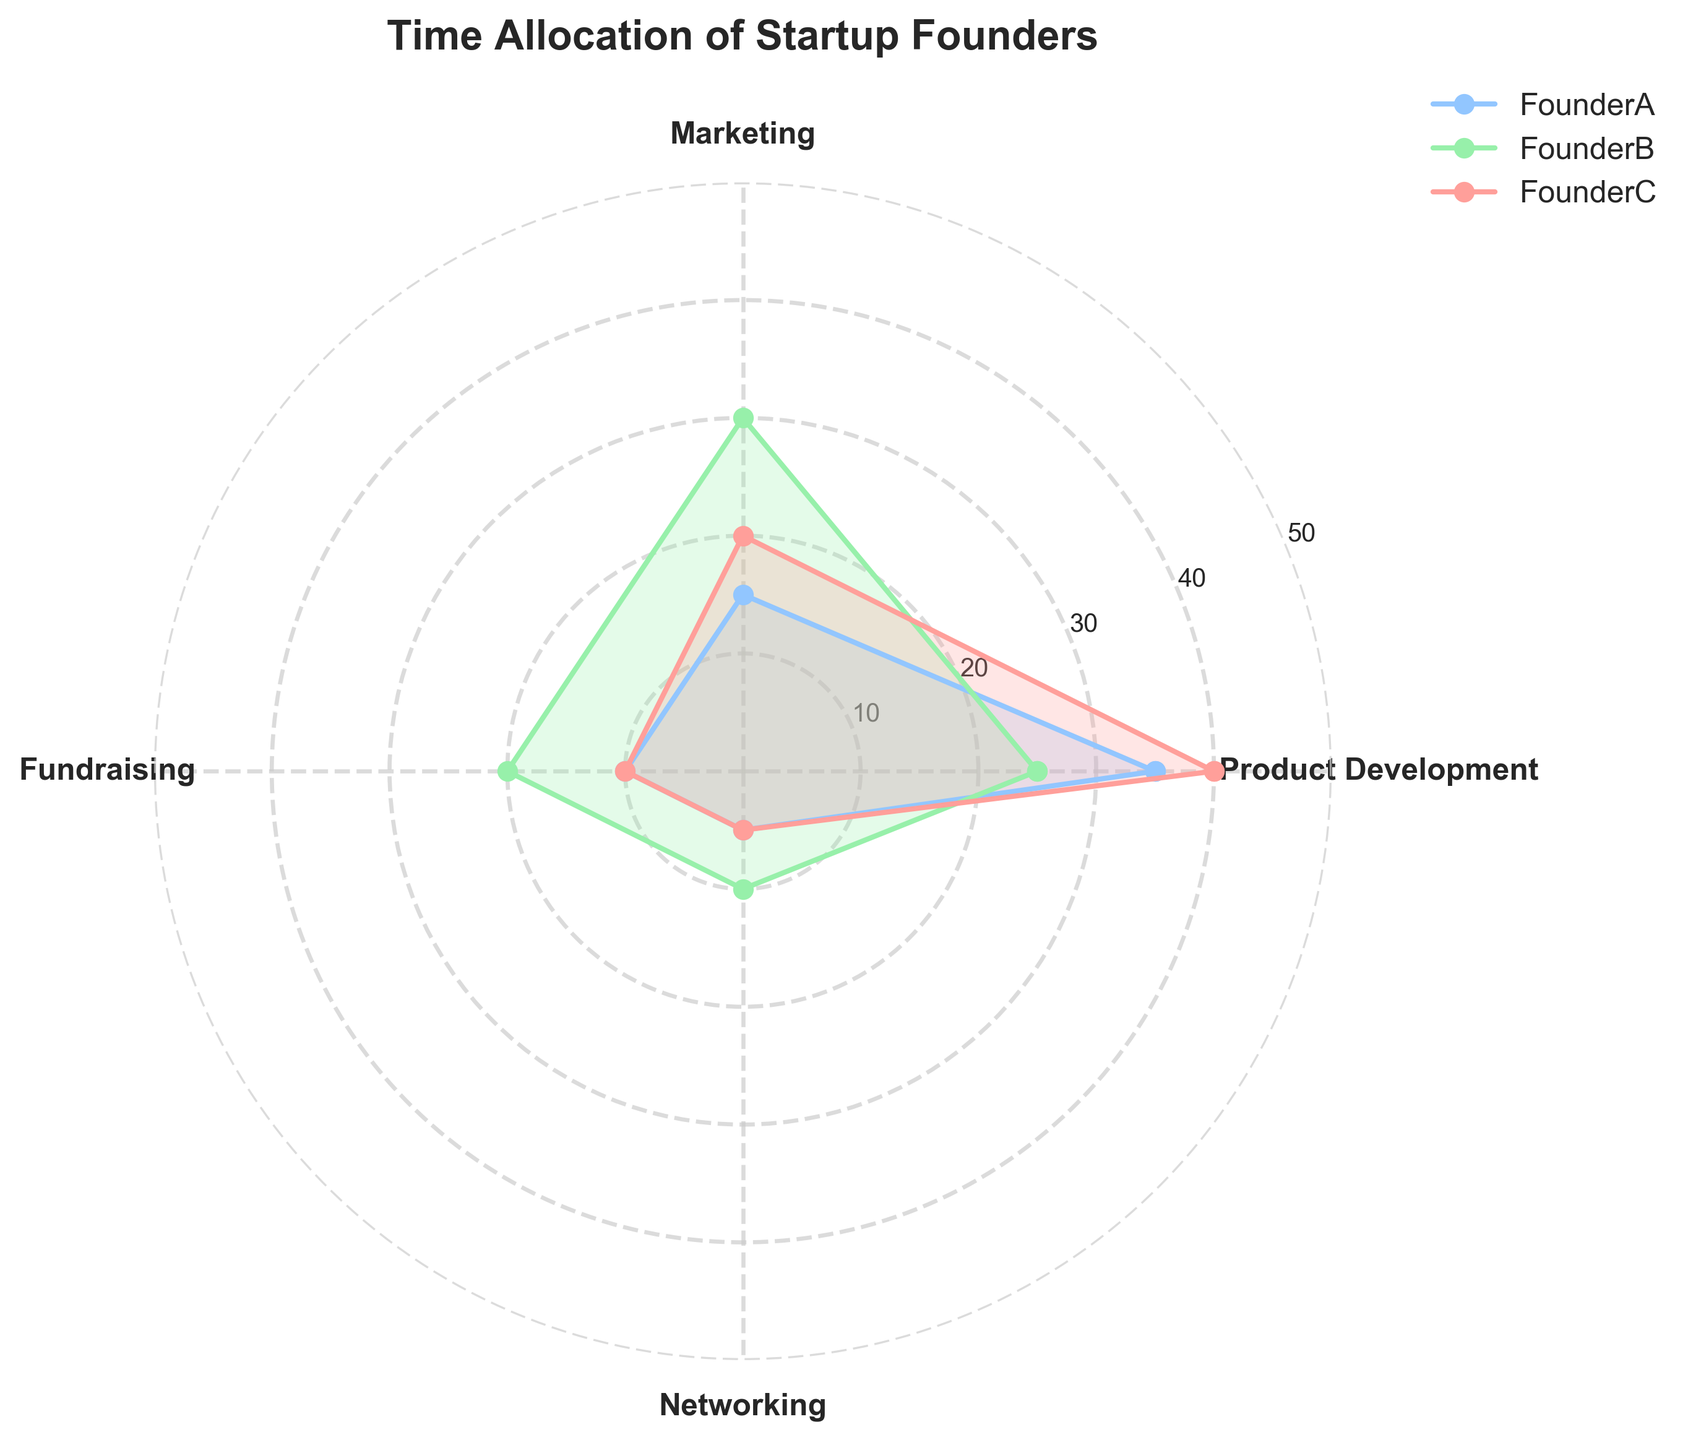What is the title of the chart? The title of the chart is displayed at the top, indicating the subject of the visual representation.
Answer: Time Allocation of Startup Founders Which founder spends the most time on product development? Look at the segment labeled "Product Development" and compare the values for each founder. FounderC has the highest value at this segment.
Answer: FounderC How many different activities are tracked in this radar chart? Count the number of distinct categories labeled around the chart's perimeter.
Answer: Four What is the total time allocated by FounderA on all activities? Sum the time allocated by FounderA across all categories: 30 (Product Development) + 20 (Marketing) + 15 (Fundraising) + 10 (Networking).
Answer: 75 hours Who spends more time on marketing, FounderA or FounderB? Compare the values for the "Marketing" segment for both FounderA and FounderB. FounderA has 20 and FounderB has 15.
Answer: FounderA What is the average number of hours spent by all founders on fundraising? Add up the values for fundraising for each founder and divide by the number of founders: (15 + 10 + 20) / 3.
Answer: 15 hours Which activity has the least time allocated by any founder, and who is that founder? Identify the minimum value for each category and check which founder represents that value. The lowest value is in Networking by FounderB with 5 hours.
Answer: Networking, FounderB How much more time does FounderC allocate to product development compared to fundraising? Subtract the time allocated to fundraising from the time allocated to product development for FounderC: 40 (Product Development) - 10 (Fundraising).
Answer: 30 hours Which founder spends an equal amount of time on networking and fundraising? Compare the values allocated to networking and fundraising for each founder. FounderB spends 10 hours on both.
Answer: FounderB How does the time spent on marketing by FounderB compare to the time spent on fundraising by FounderA and FounderC combined? Compare the value of marketing for FounderB with the sum of fundraising time by FounderA and FounderC: 30 (Marketing, FounderB) vs. 15 (Fundraising, FounderA) + 10 (Fundraising, FounderC).
Answer: FounderB spends 30 hours, which is 5 hours more 